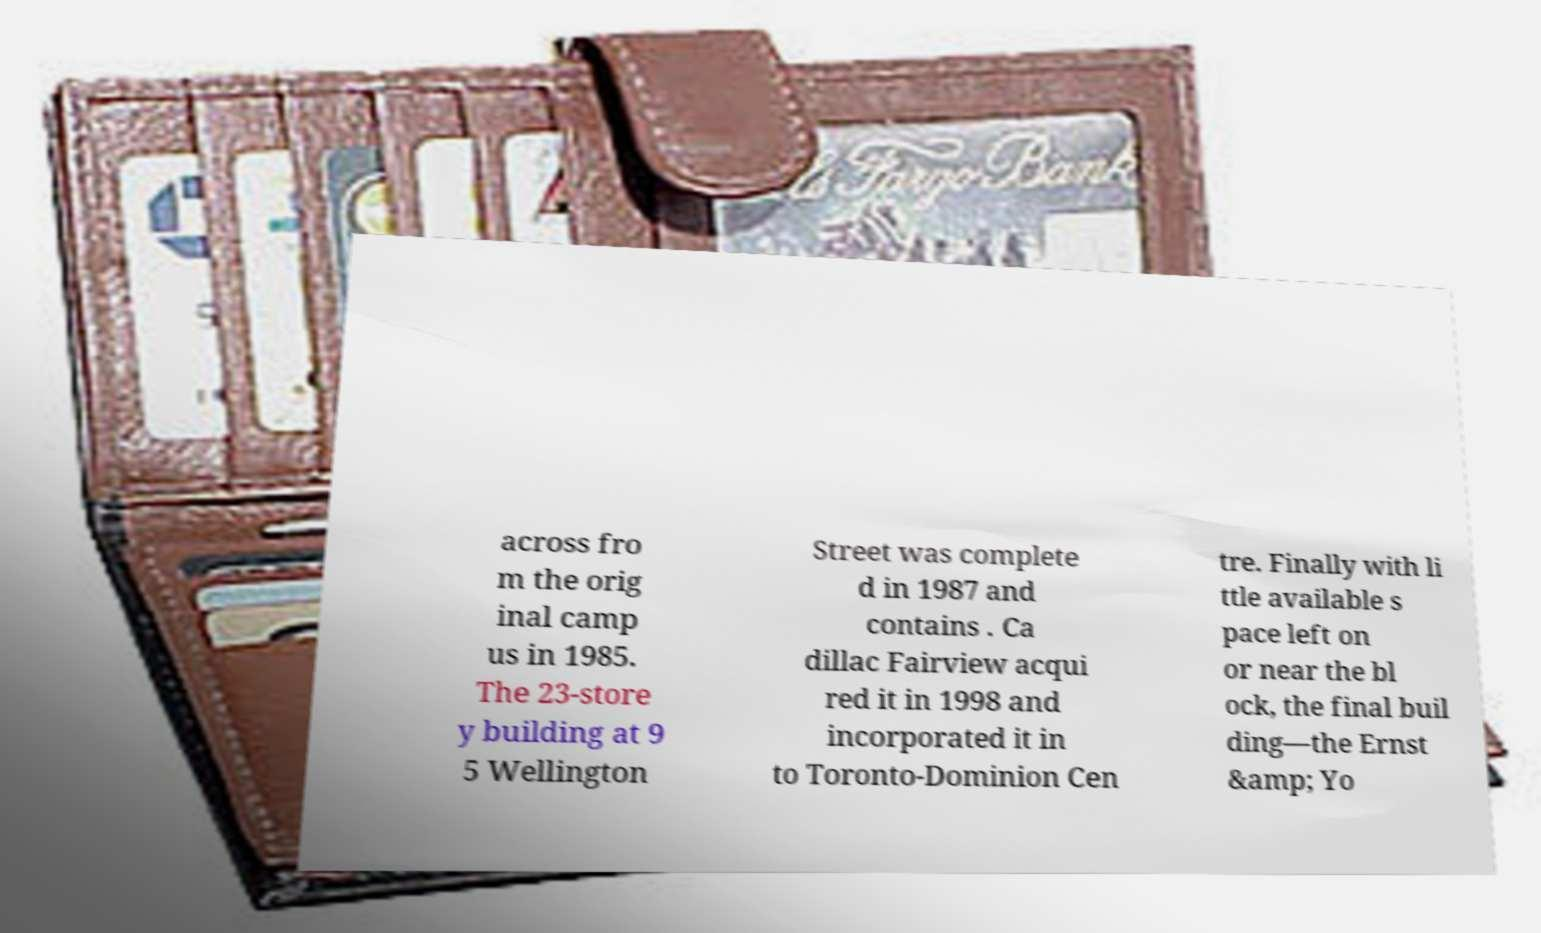For documentation purposes, I need the text within this image transcribed. Could you provide that? across fro m the orig inal camp us in 1985. The 23-store y building at 9 5 Wellington Street was complete d in 1987 and contains . Ca dillac Fairview acqui red it in 1998 and incorporated it in to Toronto-Dominion Cen tre. Finally with li ttle available s pace left on or near the bl ock, the final buil ding—the Ernst &amp; Yo 